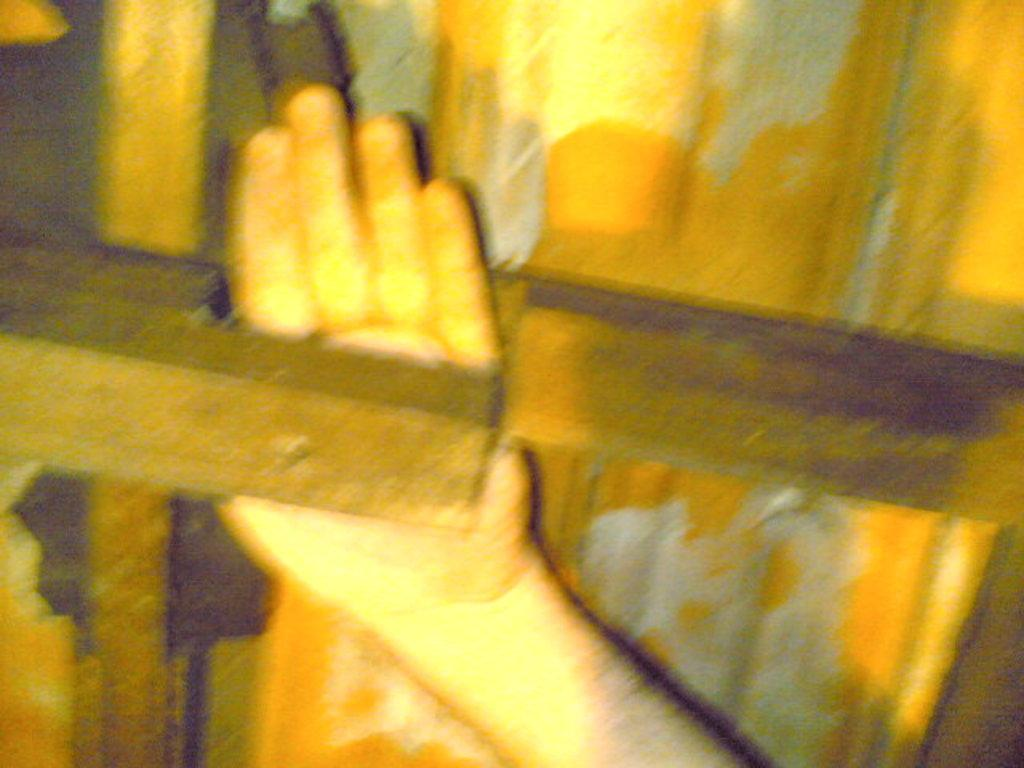What part of a person is visible in the image? There is a person's hand in the image. What type of material are the objects made of in the image? There are wooden objects in the image. Can you describe any other objects in the image besides the wooden ones? Yes, there are other objects in the image. How many babies are present in the image? There is no mention of babies in the image, so it cannot be determined if any are present. 